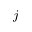<formula> <loc_0><loc_0><loc_500><loc_500>j</formula> 